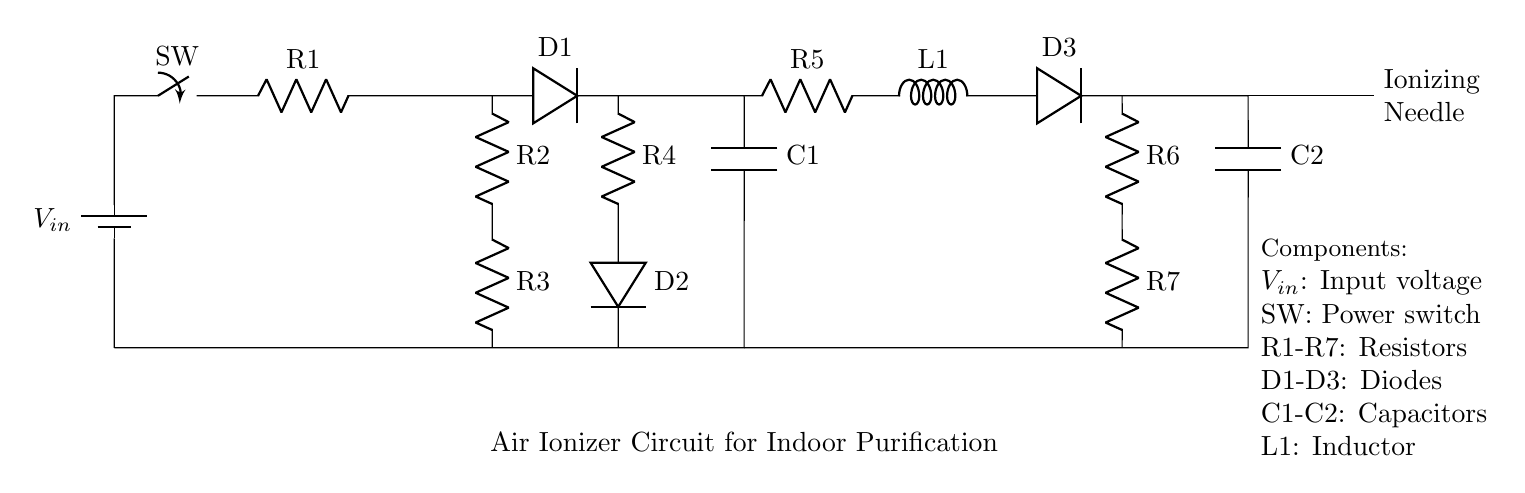What is the input voltage of this circuit? The input voltage is labeled as \(V_{in}\) in the diagram, which represents the voltage source powering the circuit.
Answer: \(V_{in}\) How many resistors are present in the circuit? The circuit diagram shows resistors labeled \(R1\) to \(R7\). Counting these, there are seven resistors in total.
Answer: 7 What is the function of the ionizing needle? The ionizing needle is responsible for generating ions, which help in purifying the air by attracting and neutralizing airborne pollutants.
Answer: Generating ions Which component is located after the first diode? After the first diode \(D1\), the next component in the circuit is the capacitor \(C1\). This is seen as the connection flows from \(D1\) to \(C1\).
Answer: Capacitor \(C1\) What is the role of the inductor in the circuit? The inductor labeled \(L1\) helps filter the current and smooth out fluctuations, contributing to stable operation. Its position in the circuit indicates it plays a role in maintaining consistent energy flow to the subsequent components.
Answer: Filtering current How are the diodes arranged in the circuit? The diodes \(D1\), \(D2\), and \(D3\) are arranged with \(D1\) in series with \(R1\), \(D2\) following \(R4\), and \(D3\) after the inductor \(L1\). This series arrangement suggests they work sequentially to direct current flow in one direction.
Answer: Series arrangement What voltage will appear across the ionizing needle when the switch is closed? When the switch is closed, voltage from the input source \(V_{in}\) will appear at the ionizing needle, assuming negligible voltage drop across the other components. Thus, the voltage at this point would be equivalent to the input voltage.
Answer: \(V_{in}\) 